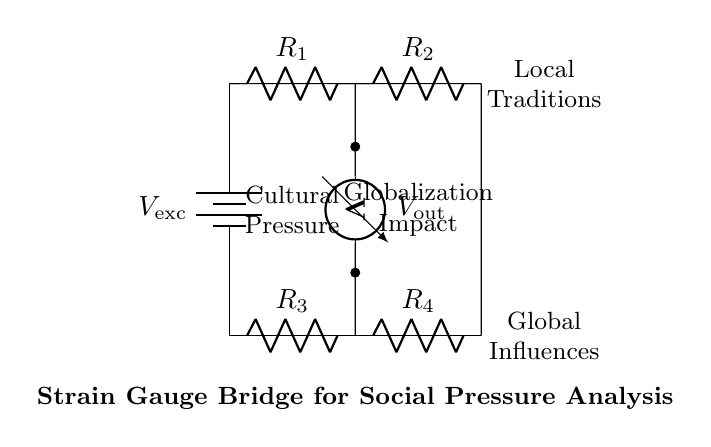What is the excitation voltage in the circuit? The excitation voltage, represented as V_exc, is the source of voltage that drives the circuit. It is clearly labeled in the diagram near the top left corner.
Answer: V_exc What do R1 and R2 represent in this circuit? R1 and R2 are resistors located in the upper part of the bridge circuit. They are responsible for balancing the bridge and measuring social pressure, indicated by their labels in the circuit diagram.
Answer: Resistors What is the output voltage measured across? The output voltage, labeled V_out, is measured between the two points indicated below R1 and R3. It reflects the difference in resistance caused by the strain gauge.
Answer: R1 and R3 How many resistors are present in the bridge? There are a total of four resistors in the circuit, labeled R1, R2, R3, and R4, which form the bridge. This can be counted directly from the circuit diagram.
Answer: Four What does the term "Cultural Pressure" refer to in this context? "Cultural Pressure" is represented in the circuit by the node label connecting R1 and R2. It signifies the influence or strain experienced by communities amid globalization, as depicted in this bridge circuit.
Answer: Influence Why is a voltmeter used in this bridge configuration? A voltmeter is utilized to measure the output voltage across the bridge, providing insight into the balance of the resistors and indicating social pressure levels. The placement of the voltmeter is shown in the diagram connecting the two nodes below R1 and R3.
Answer: Measurement 